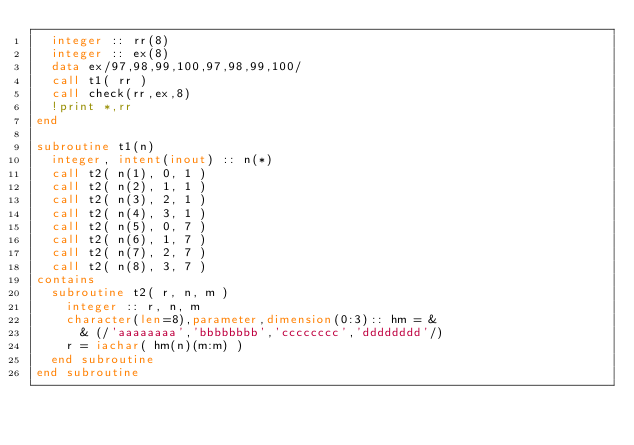<code> <loc_0><loc_0><loc_500><loc_500><_FORTRAN_>  integer :: rr(8)
  integer :: ex(8)
  data ex/97,98,99,100,97,98,99,100/
  call t1( rr )
  call check(rr,ex,8)
  !print *,rr
end

subroutine t1(n)
  integer, intent(inout) :: n(*)
  call t2( n(1), 0, 1 )
  call t2( n(2), 1, 1 )
  call t2( n(3), 2, 1 )
  call t2( n(4), 3, 1 )
  call t2( n(5), 0, 7 )
  call t2( n(6), 1, 7 )
  call t2( n(7), 2, 7 )
  call t2( n(8), 3, 7 )
contains
  subroutine t2( r, n, m )
    integer :: r, n, m
    character(len=8),parameter,dimension(0:3):: hm = &
      & (/'aaaaaaaa','bbbbbbbb','cccccccc','dddddddd'/)
    r = iachar( hm(n)(m:m) )
  end subroutine
end subroutine

</code> 